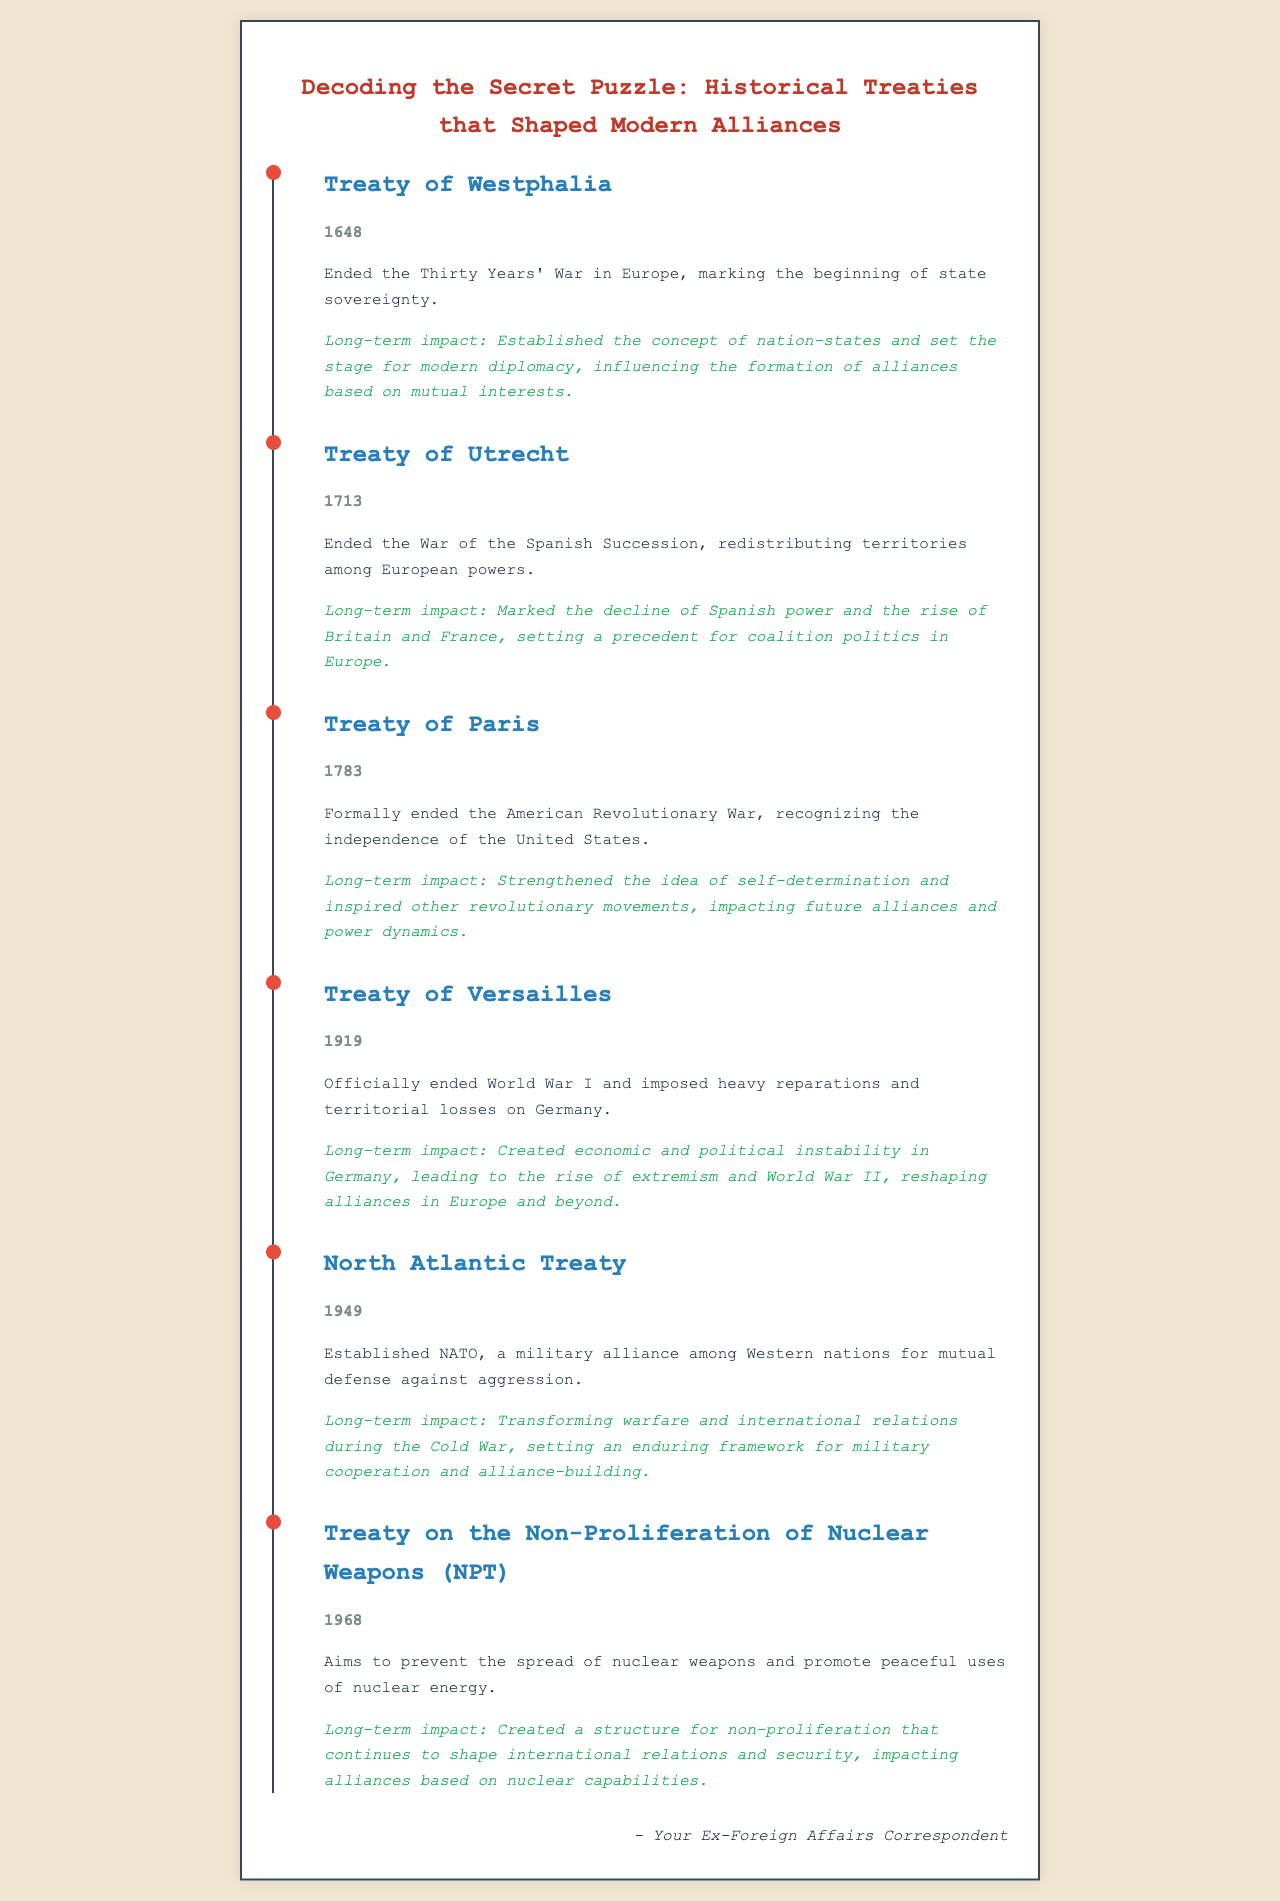What year was the Treaty of Westphalia signed? The Treaty of Westphalia is noted in the document as having taken place in 1648.
Answer: 1648 What was a long-term impact of the Treaty of Utrecht? The document states that a long-term impact of the Treaty of Utrecht was the decline of Spanish power and the rise of Britain and France.
Answer: Decline of Spanish power What does the Treaty of Paris recognize? According to the document, the Treaty of Paris formally recognizes the independence of the United States.
Answer: Independence of the United States What event did the Treaty of Versailles officially end? The document mentions that the Treaty of Versailles officially ended World War I.
Answer: World War I What military alliance was established by the North Atlantic Treaty? The North Atlantic Treaty established NATO as mentioned in the document.
Answer: NATO What is the main aim of the Treaty on the Non-Proliferation of Nuclear Weapons (NPT)? The document outlines that the main aim of the NPT is to prevent the spread of nuclear weapons.
Answer: Prevent the spread of nuclear weapons How did the Treaty of Versailles impact Germany? The document states that the Treaty of Versailles created economic and political instability in Germany.
Answer: Economic and political instability What era's framework did NATO transform according to the document? The document suggests that NATO transformed the framework of international relations during the Cold War.
Answer: Cold War What does the timeline in the document showcase? The timeline showcases significant historical treaties and their long-term impacts on modern alliances.
Answer: Significant historical treaties 